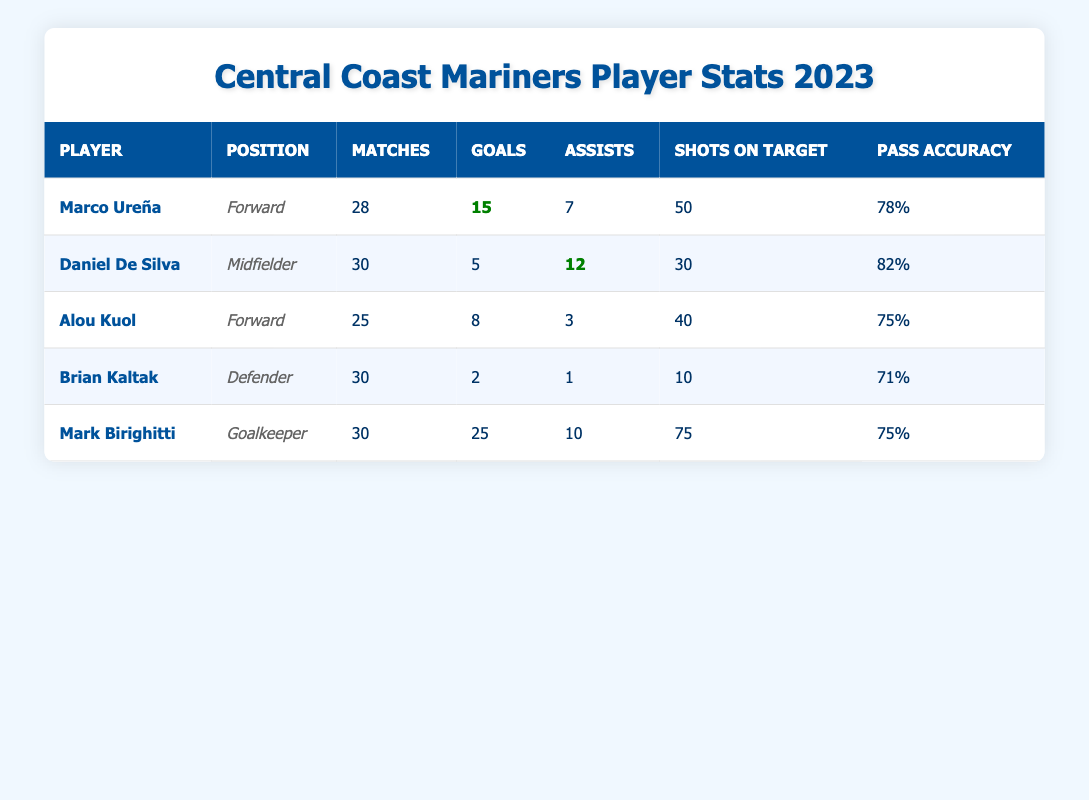What is the total number of goals scored by the forwards? The forwards listed in the table are Marco Ureña and Alou Kuol. Marco Ureña scored 15 goals and Alou Kuol scored 8 goals. Therefore, the total number of goals scored by the forwards is 15 + 8 = 23.
Answer: 23 Which player has the highest pass accuracy percentage? Looking through the pass accuracy percentages, Marco Ureña has 78%, Daniel De Silva has 82%, Alou Kuol has 75%, Brian Kaltak has 71%. The highest value is 82%, which belongs to Daniel De Silva.
Answer: Daniel De Silva Did any player score more than 10 goals in the season? We see that Marco Ureña scored 15 goals, which is greater than 10. Alou Kuol scored 8 goals, and the other players scored between 2 to 5 goals. Thus, yes, there is a player who scored over 10 goals.
Answer: Yes What is the average goals scored by all players? The total goals scored by all players is 15 (Ureña) + 5 (De Silva) + 8 (Kuol) + 2 (Kaltak) = 30 goals. There are 4 players contributing to this total. The average goals per player is 30 / 4 = 7.5.
Answer: 7.5 How many assists did Brian Kaltak provide? In the table, it is stated that Brian Kaltak provided 1 assist. Therefore, the answer to how many assists he provided is directly found in the assists column.
Answer: 1 What is the difference in goals scored between Marco Ureña and Alou Kuol? Marco Ureña scored 15 goals, while Alou Kuol scored 8 goals. To find the difference, we subtract Alou Kuol's goals from Marco Ureña's: 15 - 8 = 7.
Answer: 7 Which player has the most shots on target? Marco Ureña has 50 shots on target, Daniel De Silva has 30, Alou Kuol has 40, and Brian Kaltak has 10. Comparing these numbers, Marco Ureña has the highest at 50.
Answer: Marco Ureña What percentage of matches did Mark Birighitti keep clean sheets? Mark Birighitti has played 30 matches and kept 10 clean sheets. To find the percentage of matches he had clean sheets, we calculate (10 clean sheets / 30 matches) x 100 = 33.33%.
Answer: 33.33% 